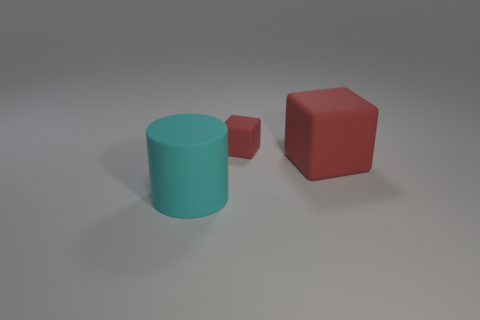What number of big rubber things are both in front of the big red rubber object and on the right side of the cyan cylinder?
Offer a terse response. 0. What material is the small object?
Provide a short and direct response. Rubber. Are there the same number of rubber cylinders that are right of the large rubber cylinder and small blue matte balls?
Make the answer very short. Yes. What number of big cyan objects have the same shape as the tiny red matte thing?
Offer a terse response. 0. Do the large red thing and the tiny red object have the same shape?
Provide a short and direct response. Yes. How many things are rubber objects behind the large cyan object or large cyan things?
Your response must be concise. 3. What is the shape of the big rubber thing left of the red rubber block behind the big matte thing that is to the right of the large cyan matte cylinder?
Make the answer very short. Cylinder. There is a cyan object that is made of the same material as the small block; what shape is it?
Your response must be concise. Cylinder. What is the size of the cyan object?
Ensure brevity in your answer.  Large. How many objects are either rubber things that are behind the large cyan rubber cylinder or big objects that are in front of the large red thing?
Offer a terse response. 3. 